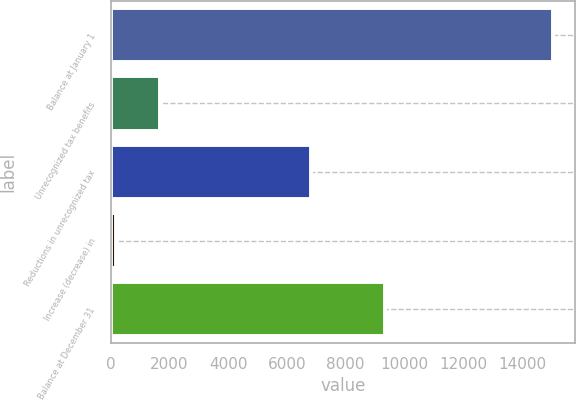Convert chart to OTSL. <chart><loc_0><loc_0><loc_500><loc_500><bar_chart><fcel>Balance at January 1<fcel>Unrecognized tax benefits<fcel>Reductions in unrecognized tax<fcel>Increase (decrease) in<fcel>Balance at December 31<nl><fcel>15054<fcel>1685.4<fcel>6813<fcel>200<fcel>9336<nl></chart> 